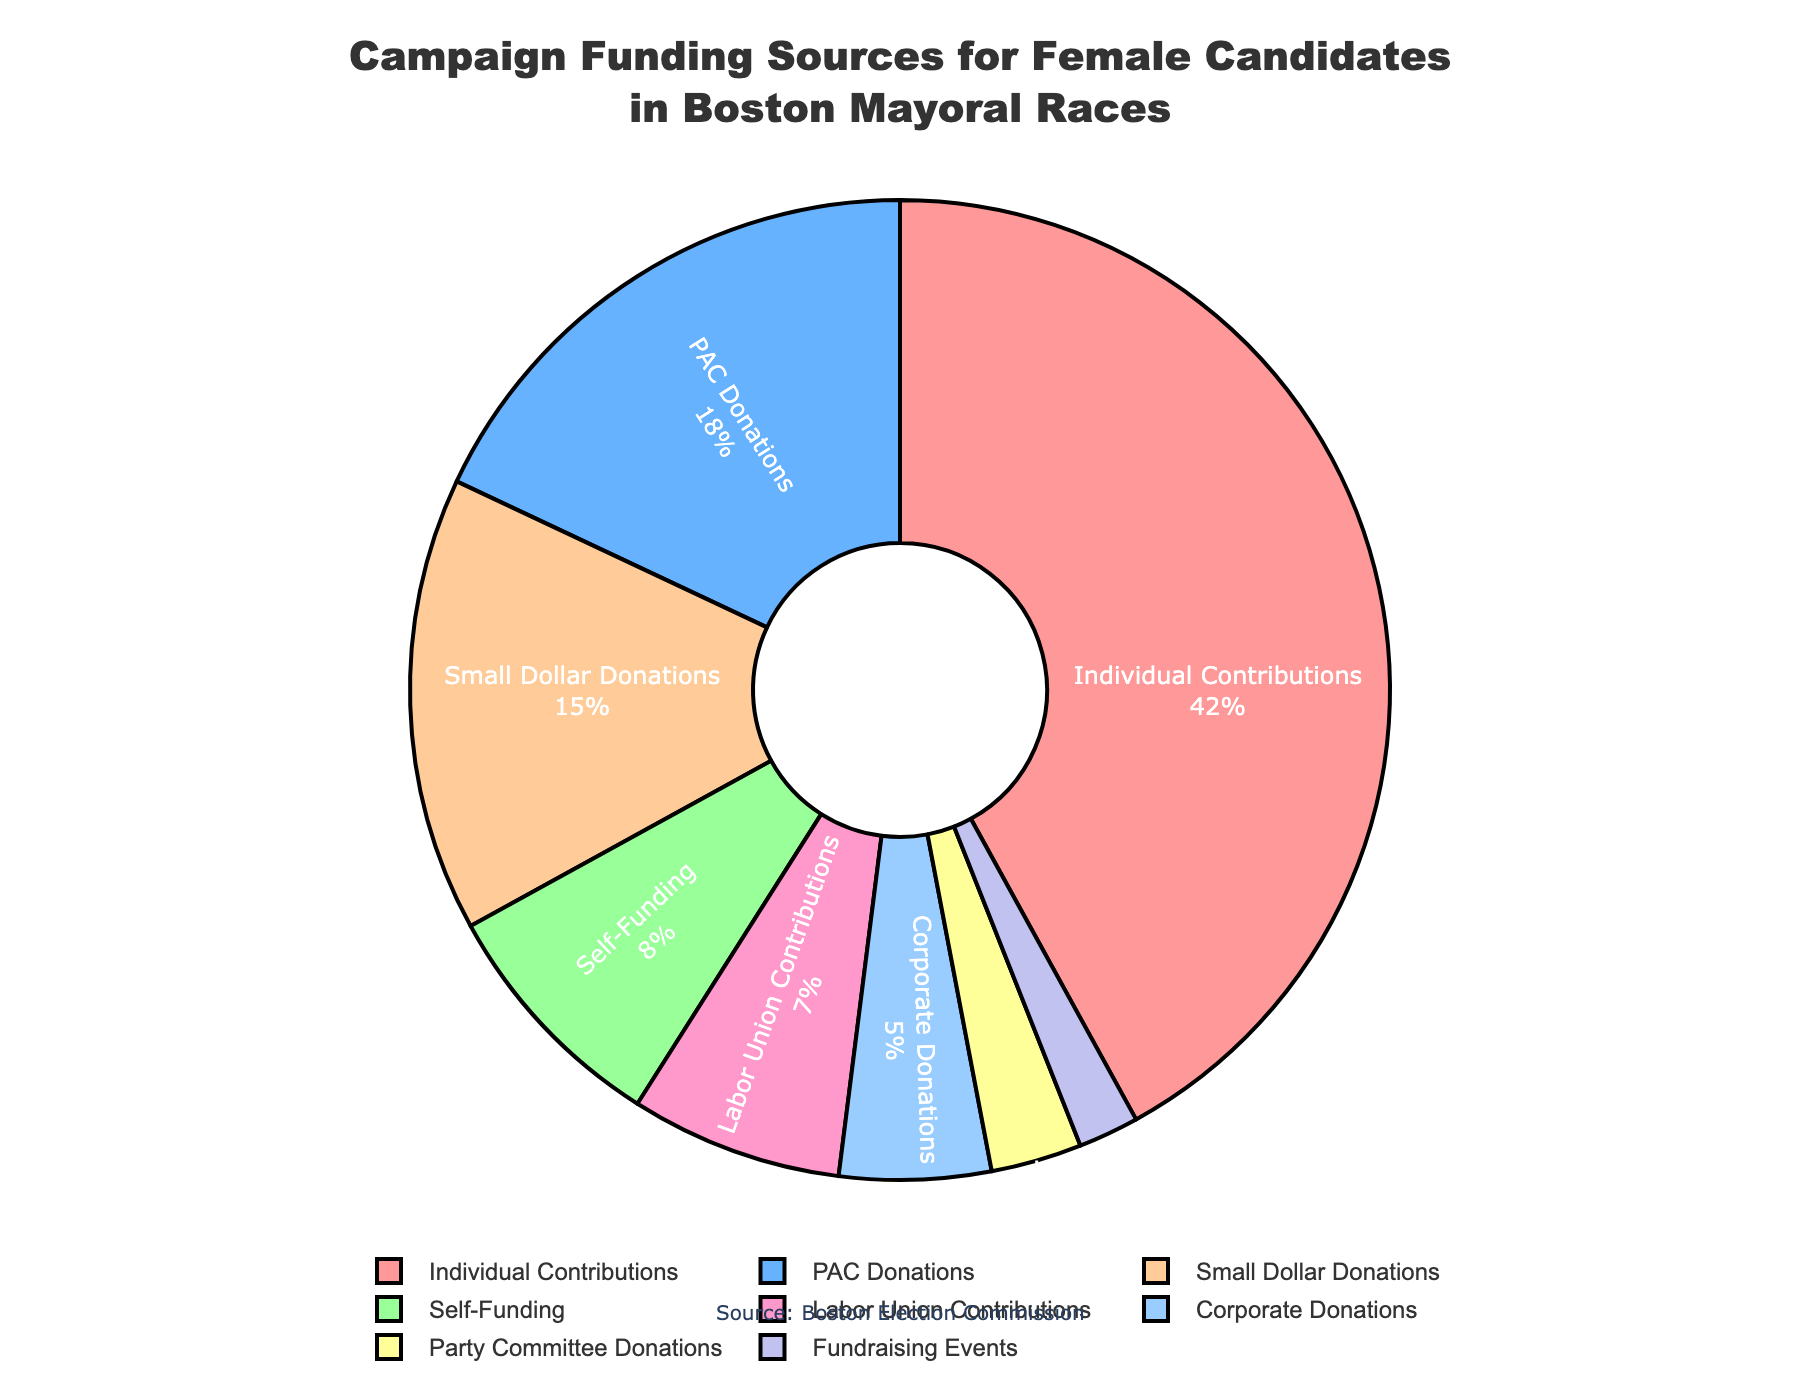What's the largest category of campaign funding for female candidates in Boston mayoral races? The category with the highest percentage in the pie chart represents the largest category of campaign funding. In this case, it is individual contributions at 42%.
Answer: Individual Contributions How much more significant are individual contributions compared to PAC donations? To find this, subtract the percentage of PAC donations from the percentage of individual contributions. This is 42% - 18% = 24%.
Answer: 24% What is the combined percentage of small dollar donations and self-funding? To calculate this, add the percentages of small dollar donations and self-funding. This is 15% + 8% = 23%.
Answer: 23% Which categories have a single-digit percentage of contributions? Categories with percentages below 10% fit this criterion. These categories are self-funding (8%), labor union contributions (7%), corporate donations (5%), party committee donations (3%), and fundraising events (2%).
Answer: Self-Funding, Labor Union Contributions, Corporate Donations, Party Committee Donations, Fundraising Events Is the sum of labor union contributions and corporate donations greater than small dollar donations? Add the percentages of labor union contributions and corporate donations and compare the result to that of small dollar donations. This is 7% + 5% = 12%, which is less than 15%.
Answer: No What's the combined total percentage of all funding sources except individual contributions? To determine this, sum the percentages of all other funding sources: 18% (PAC donations) + 8% (self-funding) + 15% (small dollar donations) + 7% (labor union contributions) + 5% (corporate donations) + 3% (party committee donations) + 2% (fundraising events) ≈ 58%.
Answer: 58% Which category has the smallest share of campaign funding sources? The category with the smallest percentage in the pie chart represents the smallest share. In this case, it is fundraising events at 2%.
Answer: Fundraising Events How does the percentage of labor union contributions compare to that of corporate donations? To compare, simply observe the percentages from the chart. Labor union contributions are 7%, while corporate donations are 5%. Thus, labor union contributions are greater.
Answer: Labor Union Contributions are greater If we combine individual contributions and PAC donations, what fraction of the total funding do they represent? Add the percentages of individual contributions and PAC donations: 42% + 18% = 60%.
Answer: 60% By how much do small dollar donations exceed party committee donations? Subtract the percentage of party committee donations from small dollar donations: 15% - 3% = 12%.
Answer: 12% 